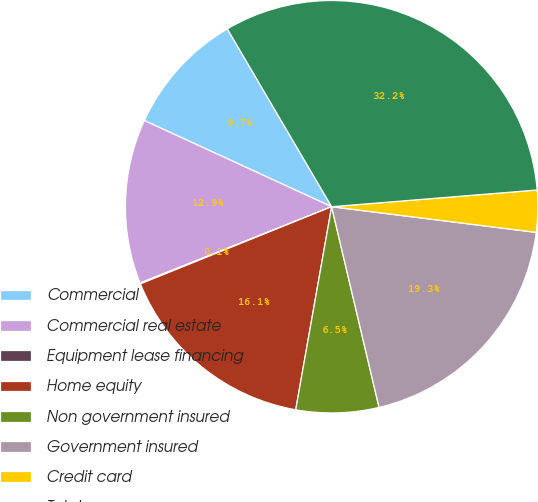<chart> <loc_0><loc_0><loc_500><loc_500><pie_chart><fcel>Commercial<fcel>Commercial real estate<fcel>Equipment lease financing<fcel>Home equity<fcel>Non government insured<fcel>Government insured<fcel>Credit card<fcel>Total<nl><fcel>9.69%<fcel>12.9%<fcel>0.07%<fcel>16.11%<fcel>6.48%<fcel>19.32%<fcel>3.28%<fcel>32.15%<nl></chart> 